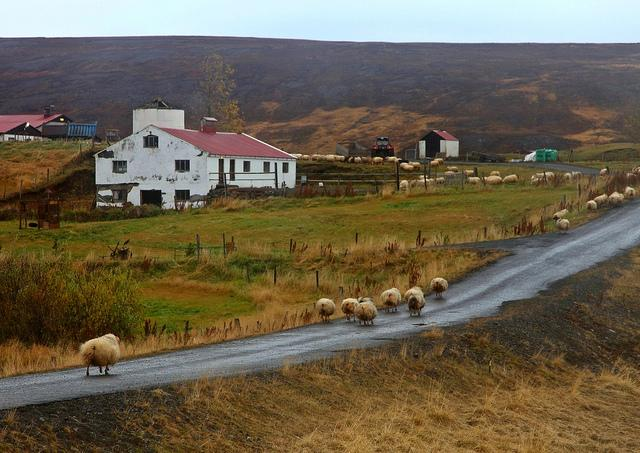What has caused the road to look slick? rain 